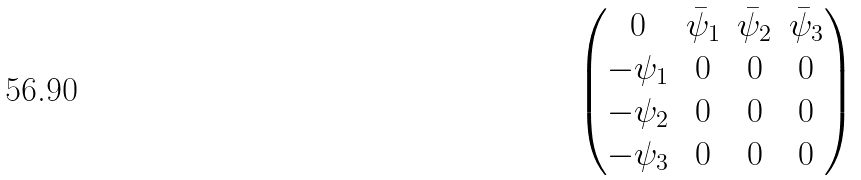Convert formula to latex. <formula><loc_0><loc_0><loc_500><loc_500>\begin{pmatrix} 0 & \bar { \psi } _ { 1 } & \bar { \psi } _ { 2 } & \bar { \psi } _ { 3 } \\ - \psi _ { 1 } & 0 & 0 & 0 \\ - \psi _ { 2 } & 0 & 0 & 0 \\ - \psi _ { 3 } & 0 & 0 & 0 \end{pmatrix}</formula> 